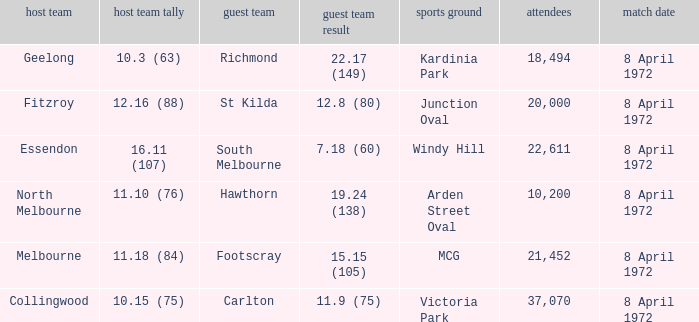Which Away team score has a Venue of kardinia park? 22.17 (149). 